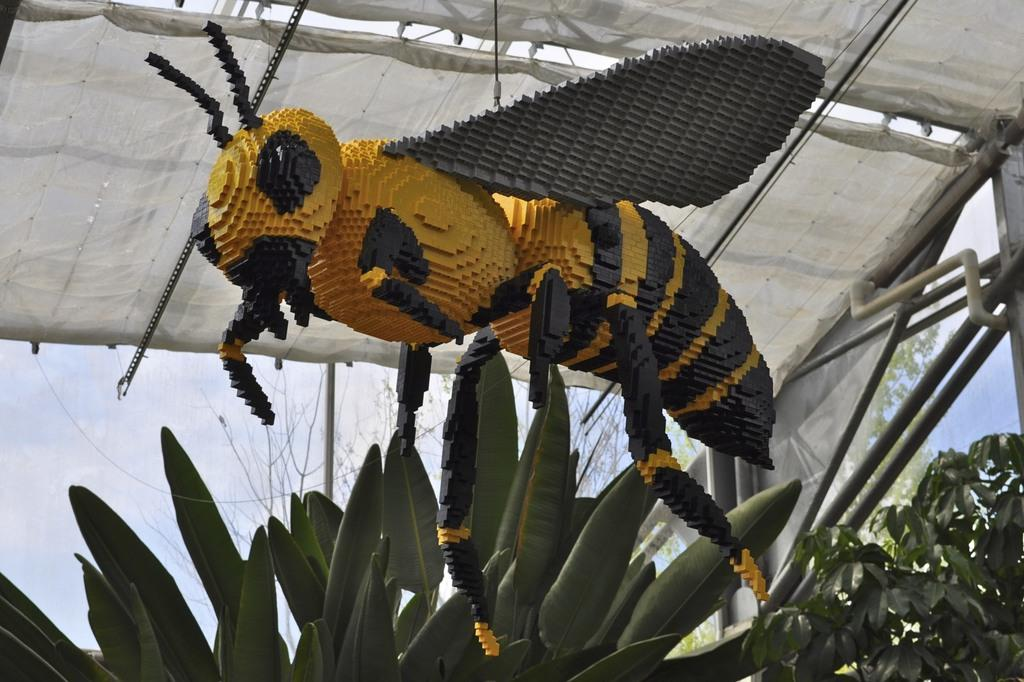What is the main subject of the image? The main subject of the image is a yellow and black color honey bee statue. How is the honey bee statue positioned in the image? The statue is hanging from the white curtain ceiling shed. What can be seen at the bottom front side of the image? There are plants visible at the bottom front side of the image. What type of zinc is used to create the selection ring in the image? There is no mention of zinc or a selection ring in the image; it features a yellow and black honey bee statue hanging from a white curtain ceiling shed with plants at the bottom front side. 